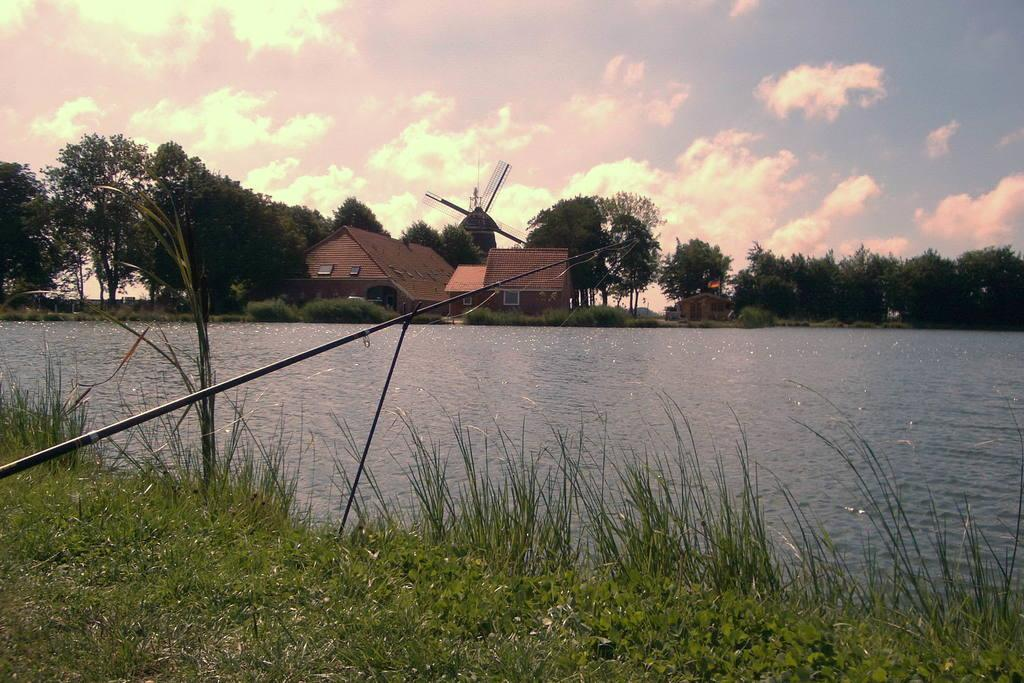What type of surface is at the bottom of the image? There is a grass surface at the bottom of the image. What can be seen in the middle of the image? There is a river and there are buildings and trees in the middle of the image. What is visible in the background of the image? The sky is visible in the background of the image. What type of muscle can be seen flexing in the image? There is no muscle present in the image. What type of leather is visible on the riverbank in the image? There is no leather visible in the image. 